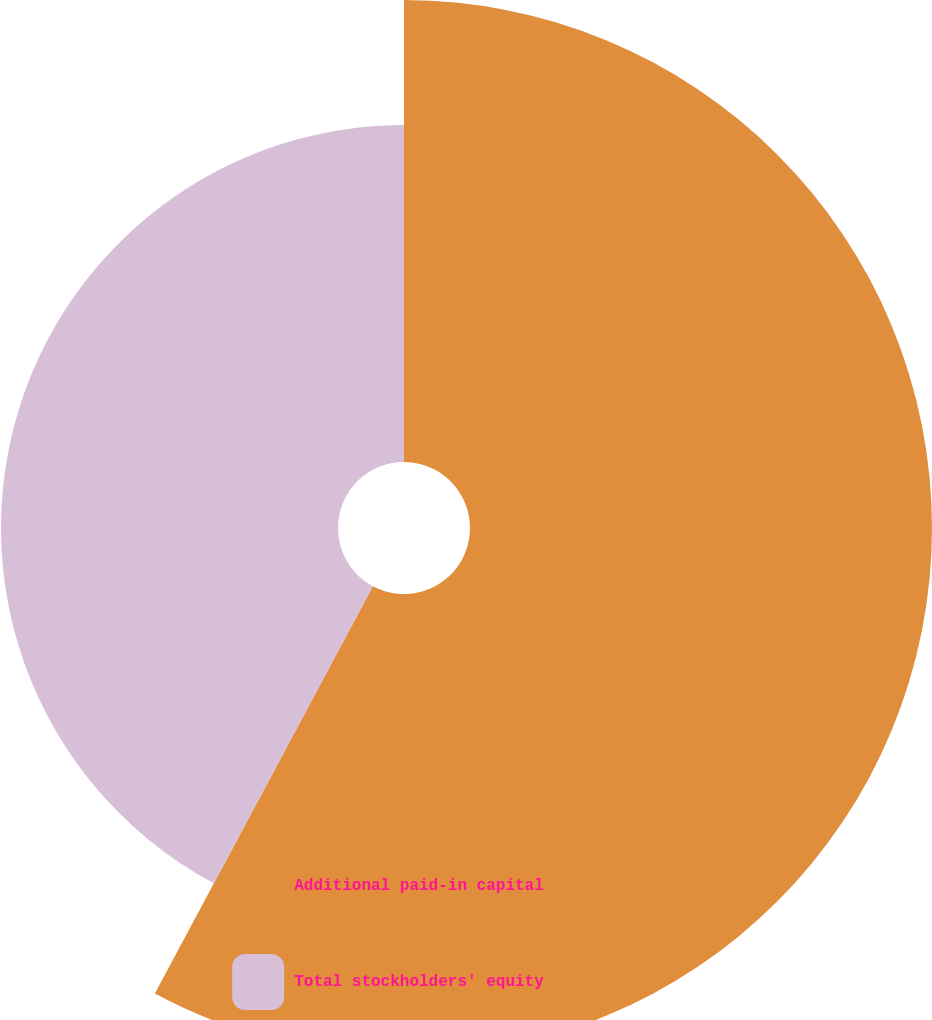Convert chart to OTSL. <chart><loc_0><loc_0><loc_500><loc_500><pie_chart><fcel>Additional paid-in capital<fcel>Total stockholders' equity<nl><fcel>57.82%<fcel>42.18%<nl></chart> 